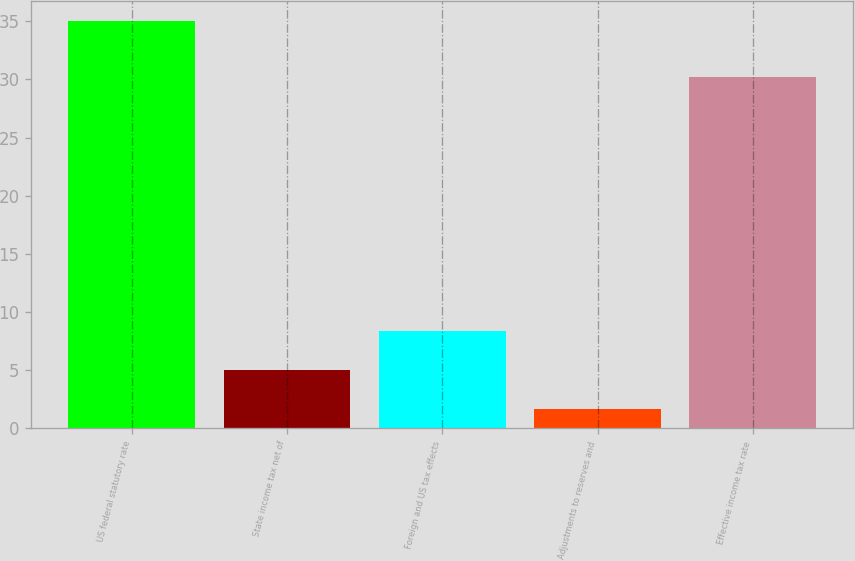Convert chart. <chart><loc_0><loc_0><loc_500><loc_500><bar_chart><fcel>US federal statutory rate<fcel>State income tax net of<fcel>Foreign and US tax effects<fcel>Adjustments to reserves and<fcel>Effective income tax rate<nl><fcel>35<fcel>5.03<fcel>8.36<fcel>1.7<fcel>30.2<nl></chart> 